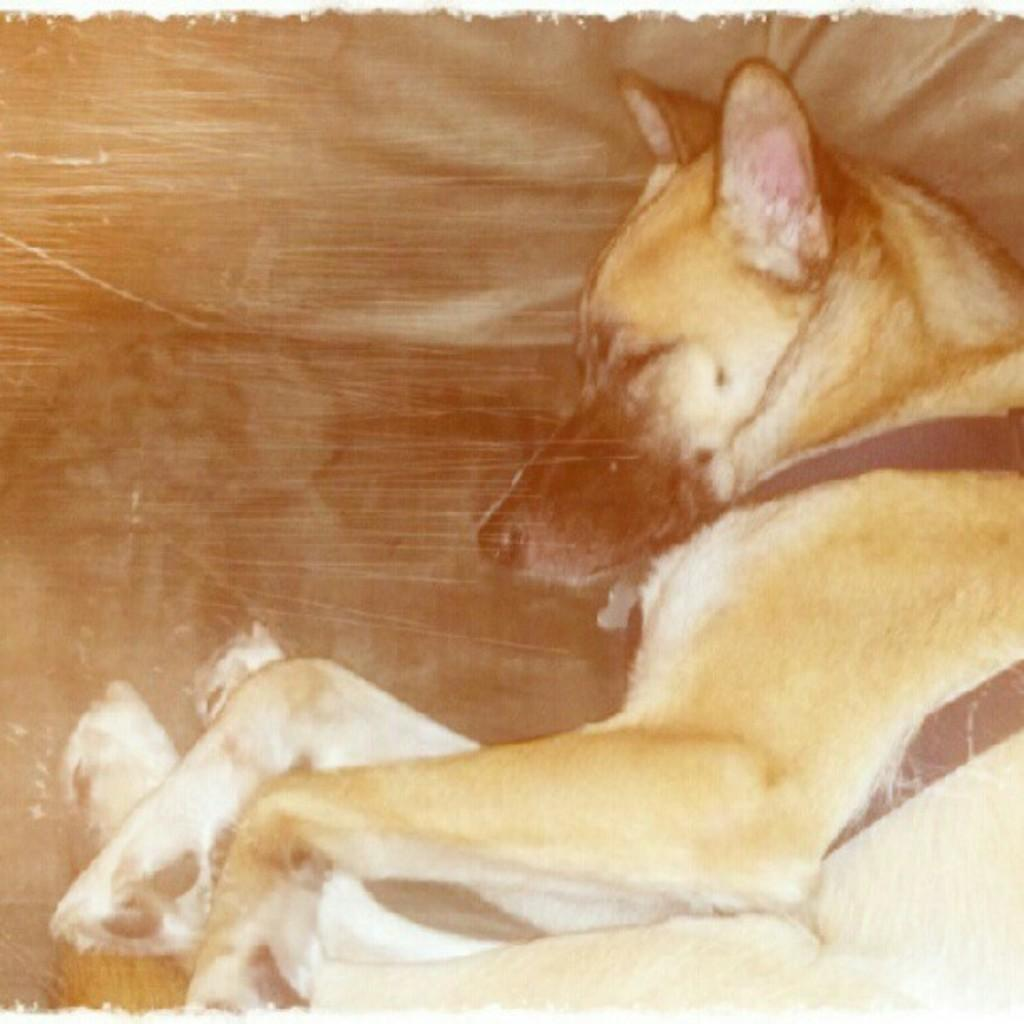What type of animal is in the image? There is a dog in the image. What is the dog doing in the image? The dog is lying down. What type of car is visible in the image? There is no car present in the image; it only features a dog lying down. How does the dog maintain its balance in the image? The dog is lying down, so balance is not a relevant factor in this image. 